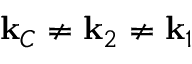Convert formula to latex. <formula><loc_0><loc_0><loc_500><loc_500>k _ { C } \neq k _ { 2 } \neq k _ { 1 }</formula> 